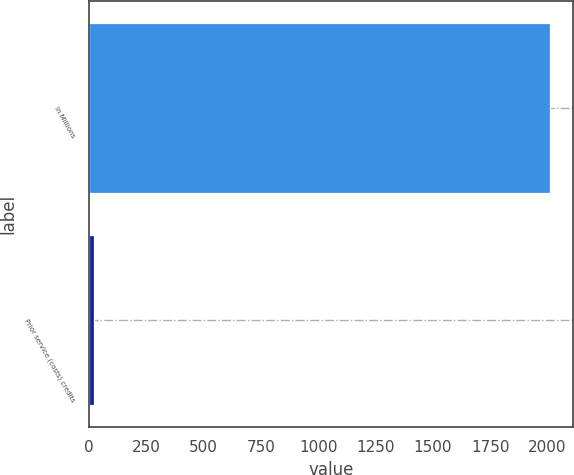<chart> <loc_0><loc_0><loc_500><loc_500><bar_chart><fcel>In Millions<fcel>Prior service (costs) credits<nl><fcel>2011<fcel>20.7<nl></chart> 